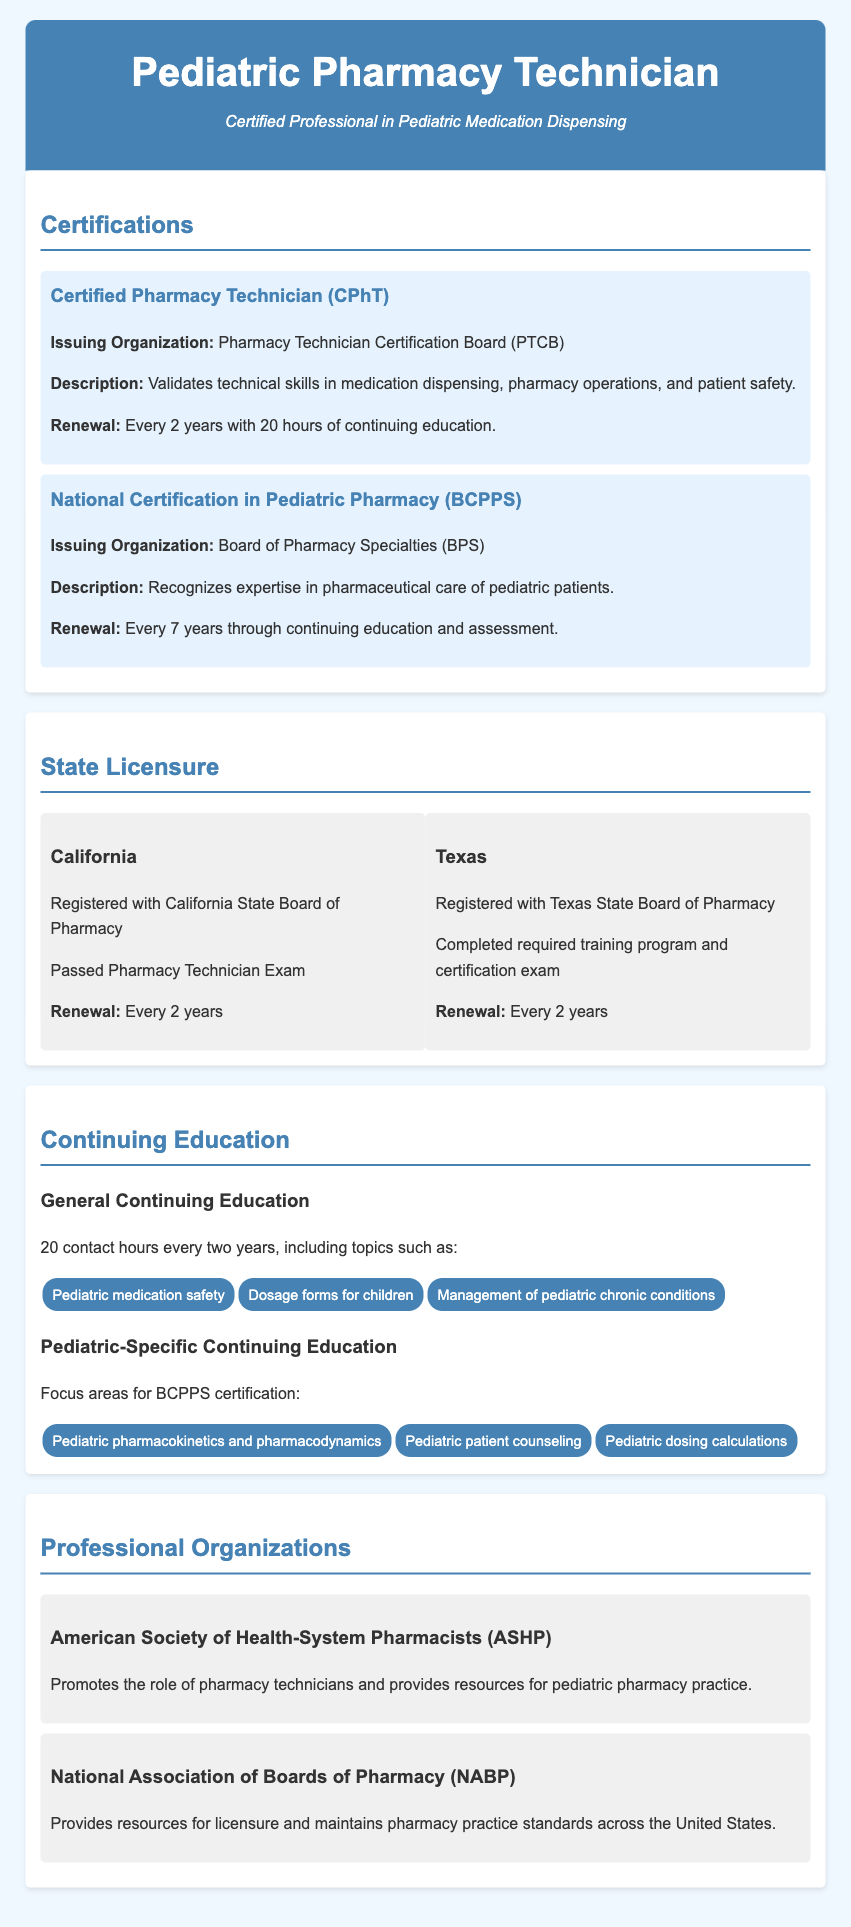what is the certification name for pharmacy technicians? The certification name for pharmacy technicians mentioned in the document is "Certified Pharmacy Technician (CPhT)."
Answer: Certified Pharmacy Technician (CPhT) who issues the National Certification in Pediatric Pharmacy? The issuing organization for the National Certification in Pediatric Pharmacy is specified in the document.
Answer: Board of Pharmacy Specialties (BPS) how often must the CPhT certification be renewed? The document states how frequently the CPhT certification must be renewed.
Answer: Every 2 years what are the requirements for renewals of the BCPPS certification? The requirements for the renewal of the BCPPS certification include completing continuing education and assessment, as stated in the document.
Answer: Continuing education and assessment which two states are listed under state licensure? The document lists specific states under state licensure, and the two are readily identifiable.
Answer: California and Texas what is one focus area for pediatric-specific continuing education? The document provides specific focus areas for pediatric continuing education, and one can be extracted directly from it.
Answer: Pediatric pharmacokinetics and pharmacodynamics what is the organization that promotes resources for pediatric pharmacy practice? The document identifies an organization focused on supporting pediatric pharmacy practices.
Answer: American Society of Health-System Pharmacists (ASHP) how many hours of continuing education are needed to maintain CPhT certification? The document specifies the number of hours required for continuing education to maintain the CPhT certification.
Answer: 20 hours 